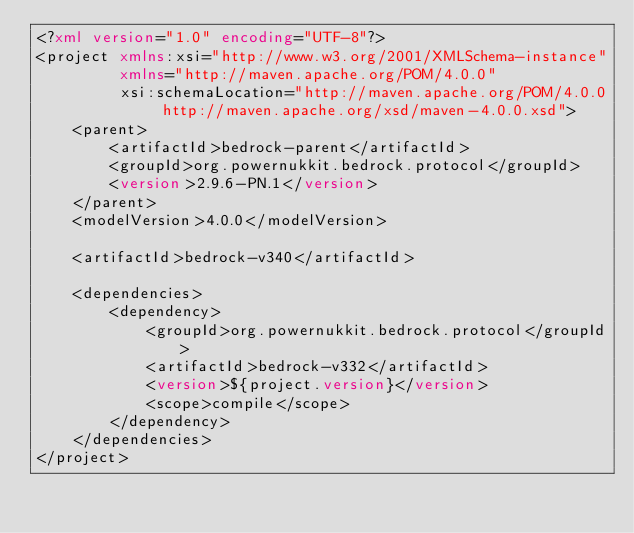Convert code to text. <code><loc_0><loc_0><loc_500><loc_500><_XML_><?xml version="1.0" encoding="UTF-8"?>
<project xmlns:xsi="http://www.w3.org/2001/XMLSchema-instance"
         xmlns="http://maven.apache.org/POM/4.0.0"
         xsi:schemaLocation="http://maven.apache.org/POM/4.0.0 http://maven.apache.org/xsd/maven-4.0.0.xsd">
    <parent>
        <artifactId>bedrock-parent</artifactId>
        <groupId>org.powernukkit.bedrock.protocol</groupId>
        <version>2.9.6-PN.1</version>
    </parent>
    <modelVersion>4.0.0</modelVersion>

    <artifactId>bedrock-v340</artifactId>

    <dependencies>
        <dependency>
            <groupId>org.powernukkit.bedrock.protocol</groupId>
            <artifactId>bedrock-v332</artifactId>
            <version>${project.version}</version>
            <scope>compile</scope>
        </dependency>
    </dependencies>
</project>


</code> 